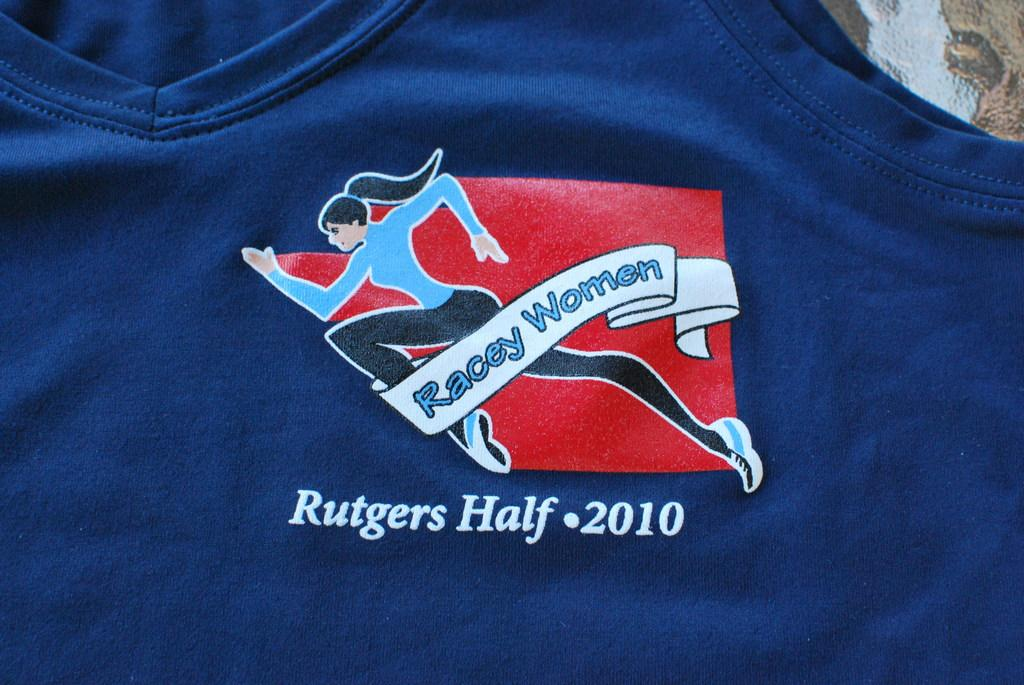<image>
Give a short and clear explanation of the subsequent image. A teeshirt patch for women racing in the 2010 Rutgers half has a red background. 